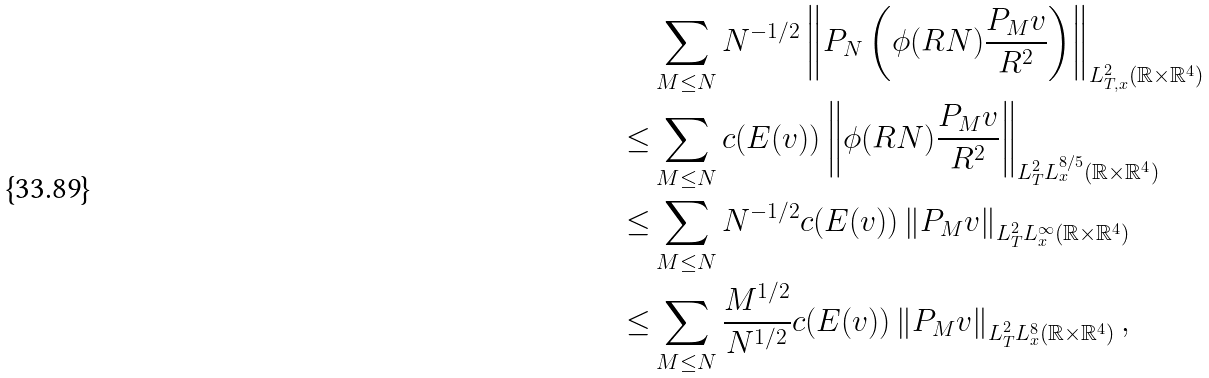<formula> <loc_0><loc_0><loc_500><loc_500>& \sum _ { M \leq N } N ^ { - 1 / 2 } \left \| P _ { N } \left ( \phi ( R N ) \frac { P _ { M } v } { R ^ { 2 } } \right ) \right \| _ { L _ { T , x } ^ { 2 } ( \mathbb { R } \times \mathbb { R } ^ { 4 } ) } \\ \leq & \sum _ { M \leq N } c ( E ( v ) ) \left \| \phi ( R N ) \frac { P _ { M } v } { R ^ { 2 } } \right \| _ { L _ { T } ^ { 2 } L _ { x } ^ { 8 / 5 } ( \mathbb { R } \times \mathbb { R } ^ { 4 } ) } \\ \leq & \sum _ { M \leq N } N ^ { - 1 / 2 } c ( E ( v ) ) \left \| P _ { M } v \right \| _ { L _ { T } ^ { 2 } L _ { x } ^ { \infty } ( \mathbb { R } \times \mathbb { R } ^ { 4 } ) } \\ \leq & \sum _ { M \leq N } \frac { M ^ { 1 / 2 } } { N ^ { 1 / 2 } } c ( E ( v ) ) \left \| P _ { M } v \right \| _ { L _ { T } ^ { 2 } L _ { x } ^ { 8 } ( \mathbb { R } \times \mathbb { R } ^ { 4 } ) } ,</formula> 